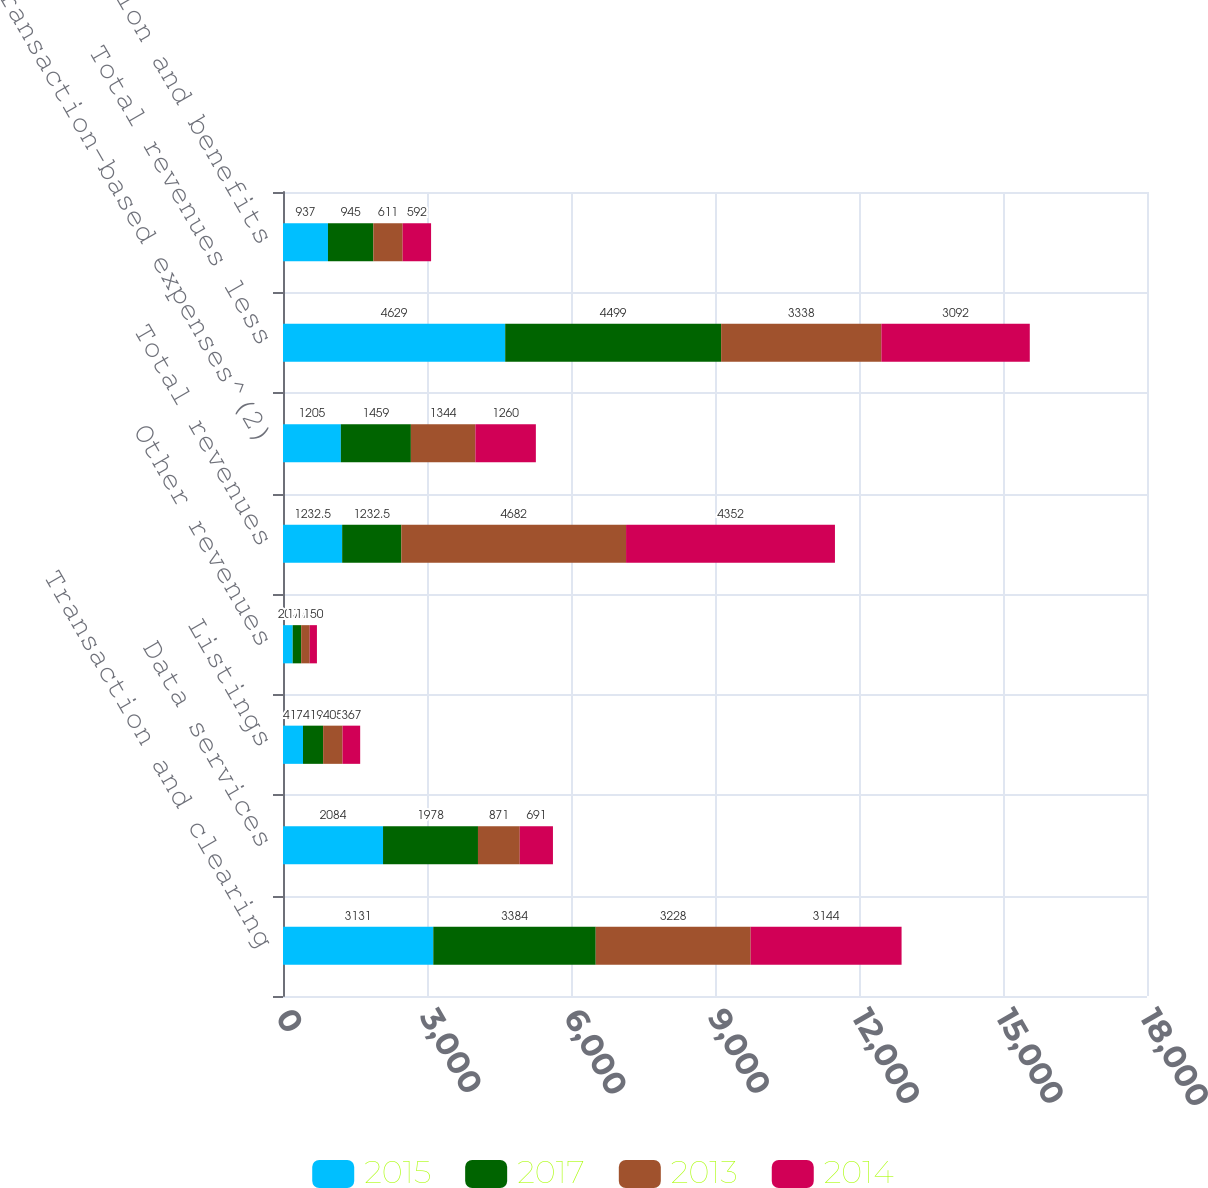Convert chart. <chart><loc_0><loc_0><loc_500><loc_500><stacked_bar_chart><ecel><fcel>Transaction and clearing<fcel>Data services<fcel>Listings<fcel>Other revenues<fcel>Total revenues<fcel>Transaction-based expenses^(2)<fcel>Total revenues less<fcel>Compensation and benefits<nl><fcel>2015<fcel>3131<fcel>2084<fcel>417<fcel>202<fcel>1232.5<fcel>1205<fcel>4629<fcel>937<nl><fcel>2017<fcel>3384<fcel>1978<fcel>419<fcel>177<fcel>1232.5<fcel>1459<fcel>4499<fcel>945<nl><fcel>2013<fcel>3228<fcel>871<fcel>405<fcel>178<fcel>4682<fcel>1344<fcel>3338<fcel>611<nl><fcel>2014<fcel>3144<fcel>691<fcel>367<fcel>150<fcel>4352<fcel>1260<fcel>3092<fcel>592<nl></chart> 